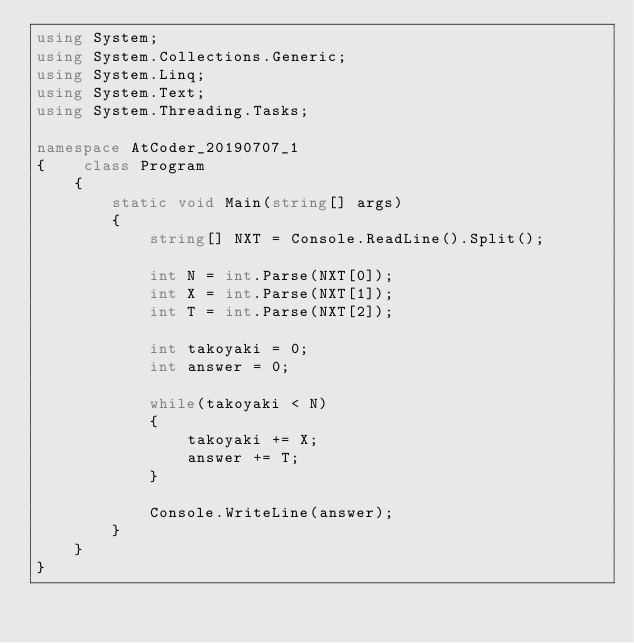Convert code to text. <code><loc_0><loc_0><loc_500><loc_500><_C#_>using System;
using System.Collections.Generic;
using System.Linq;
using System.Text;
using System.Threading.Tasks;

namespace AtCoder_20190707_1
{    class Program
    {
        static void Main(string[] args)
        {
            string[] NXT = Console.ReadLine().Split();

            int N = int.Parse(NXT[0]);
            int X = int.Parse(NXT[1]);
            int T = int.Parse(NXT[2]);

            int takoyaki = 0;
            int answer = 0;

            while(takoyaki < N)
            {
                takoyaki += X;
                answer += T;
            }

            Console.WriteLine(answer);
        }
    }
}</code> 